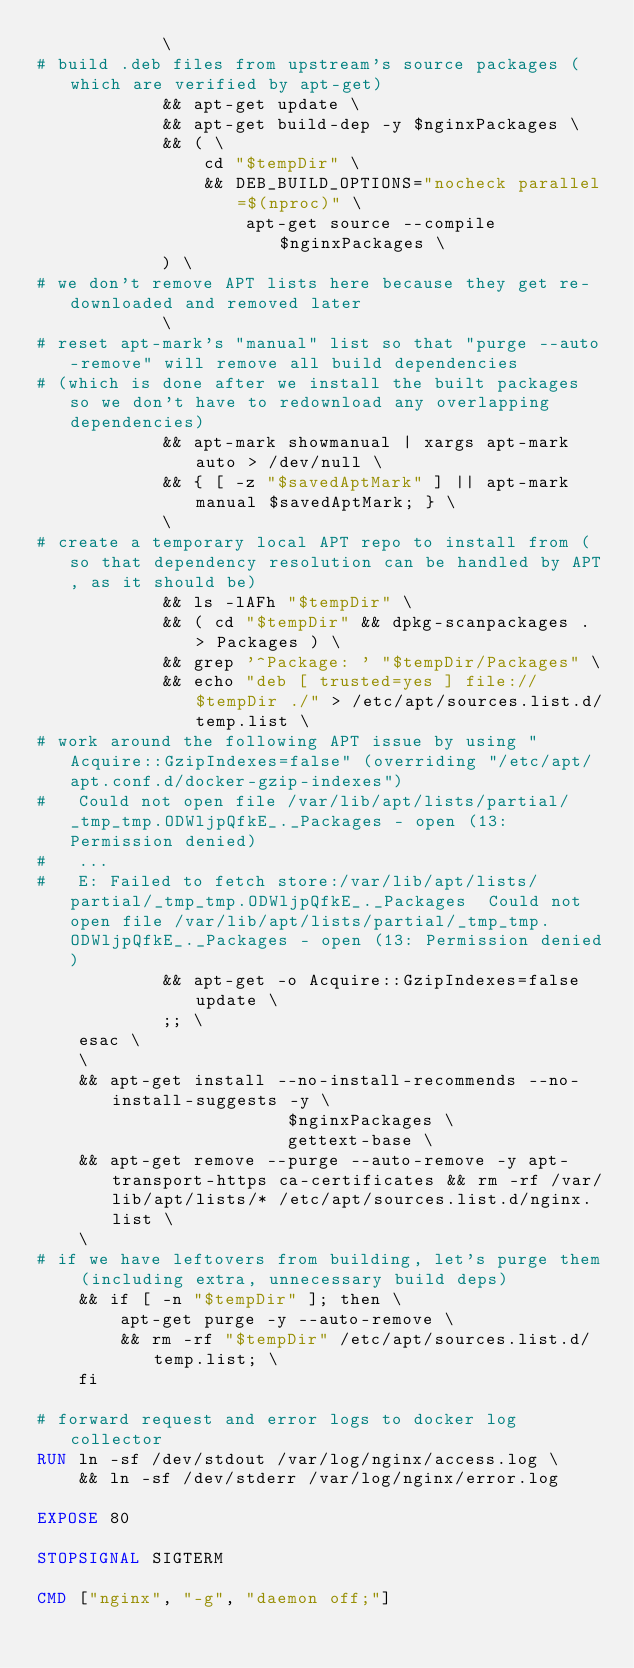<code> <loc_0><loc_0><loc_500><loc_500><_Dockerfile_>            \
# build .deb files from upstream's source packages (which are verified by apt-get)
            && apt-get update \
            && apt-get build-dep -y $nginxPackages \
            && ( \
                cd "$tempDir" \
                && DEB_BUILD_OPTIONS="nocheck parallel=$(nproc)" \
                    apt-get source --compile $nginxPackages \
            ) \
# we don't remove APT lists here because they get re-downloaded and removed later
            \
# reset apt-mark's "manual" list so that "purge --auto-remove" will remove all build dependencies
# (which is done after we install the built packages so we don't have to redownload any overlapping dependencies)
            && apt-mark showmanual | xargs apt-mark auto > /dev/null \
            && { [ -z "$savedAptMark" ] || apt-mark manual $savedAptMark; } \
            \
# create a temporary local APT repo to install from (so that dependency resolution can be handled by APT, as it should be)
            && ls -lAFh "$tempDir" \
            && ( cd "$tempDir" && dpkg-scanpackages . > Packages ) \
            && grep '^Package: ' "$tempDir/Packages" \
            && echo "deb [ trusted=yes ] file://$tempDir ./" > /etc/apt/sources.list.d/temp.list \
# work around the following APT issue by using "Acquire::GzipIndexes=false" (overriding "/etc/apt/apt.conf.d/docker-gzip-indexes")
#   Could not open file /var/lib/apt/lists/partial/_tmp_tmp.ODWljpQfkE_._Packages - open (13: Permission denied)
#   ...
#   E: Failed to fetch store:/var/lib/apt/lists/partial/_tmp_tmp.ODWljpQfkE_._Packages  Could not open file /var/lib/apt/lists/partial/_tmp_tmp.ODWljpQfkE_._Packages - open (13: Permission denied)
            && apt-get -o Acquire::GzipIndexes=false update \
            ;; \
    esac \
    \
    && apt-get install --no-install-recommends --no-install-suggests -y \
                        $nginxPackages \
                        gettext-base \
    && apt-get remove --purge --auto-remove -y apt-transport-https ca-certificates && rm -rf /var/lib/apt/lists/* /etc/apt/sources.list.d/nginx.list \
    \
# if we have leftovers from building, let's purge them (including extra, unnecessary build deps)
    && if [ -n "$tempDir" ]; then \
        apt-get purge -y --auto-remove \
        && rm -rf "$tempDir" /etc/apt/sources.list.d/temp.list; \
    fi

# forward request and error logs to docker log collector
RUN ln -sf /dev/stdout /var/log/nginx/access.log \
    && ln -sf /dev/stderr /var/log/nginx/error.log

EXPOSE 80

STOPSIGNAL SIGTERM

CMD ["nginx", "-g", "daemon off;"]
</code> 